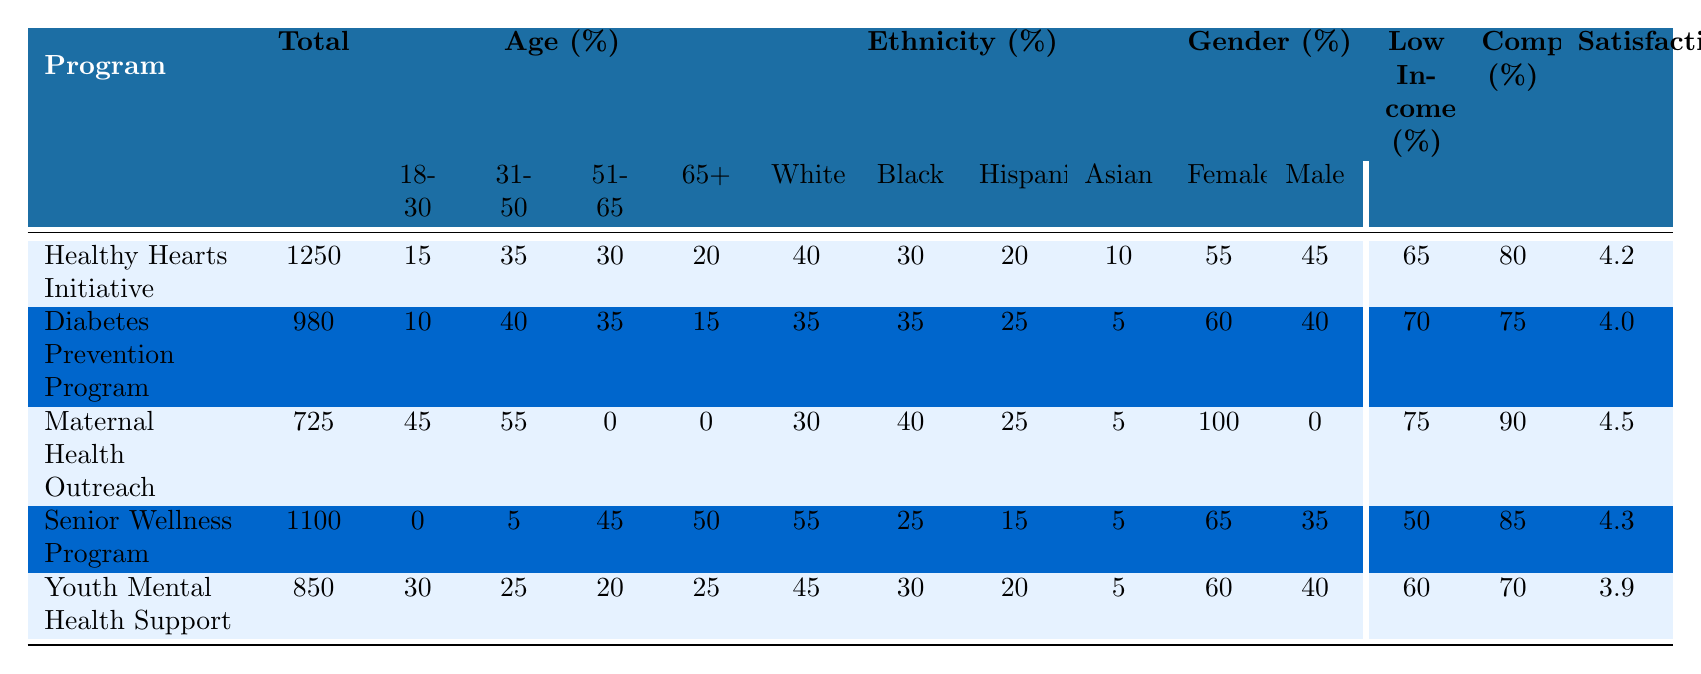What is the completion rate for the Youth Mental Health Support program? The completion rate for the Youth Mental Health Support program can be found in the table under the "Completion (%)" column. It shows a value of 70.
Answer: 70 Which program has the highest percentage of female participants? By looking at the "Female (%)" column, Maternal Health Outreach has a percentage of 100, which is the highest among all programs.
Answer: Maternal Health Outreach What is the total number of participants across all programs? To find the total number of participants, we sum up the values in the "Total" column: 1250 + 980 + 725 + 1100 + 850 = 4005.
Answer: 4005 What age group has the highest percentage of participants in the Diabetes Prevention Program? In the "Age (%)" section for the Diabetes Prevention Program, the highest percentage is in the 31-50 age group, which is 40.
Answer: 31-50 age group Is there any program that has a completion rate of 90%? By checking the "Completion (%)" column, we see that only the Maternal Health Outreach program has a completion rate of 90%.
Answer: Yes What percentage of participants in the Senior Wellness Program are low income? The "Low Income (%)" column for the Senior Wellness Program shows a percentage of 50.
Answer: 50 Which demographic group has the lowest participation rate overall? To determine this, we compare the percentages of each age group across all programs. The age group 65+ has the lowest overall participation rates, especially in the Healthy Hearts Initiative and Maternal Health Outreach.
Answer: 65+ Calculate the average satisfaction score of all programs. To calculate the average satisfaction score, we sum the scores: 4.2 + 4.0 + 4.5 + 4.3 + 3.9 = 20.9. Then we divide by the number of programs (5): 20.9 / 5 = 4.18.
Answer: 4.18 How does the percentage of Black participants in the Maternal Health Outreach compare to the Senior Wellness Program? The percentage of Black participants in the Maternal Health Outreach program is 40%, while for the Senior Wellness Program it is 25%. Therefore, Maternal Health Outreach has a higher percentage of Black participants compared to Senior Wellness Program.
Answer: Higher in Maternal Health Outreach In which program do participants aged 51-65 have the highest percentage? Referring to the "Age (%)" section, the Maternal Health Outreach program has 0% of participants aged 51-65, while the Senior Wellness Program has 45%, which is the highest.
Answer: Senior Wellness Program 